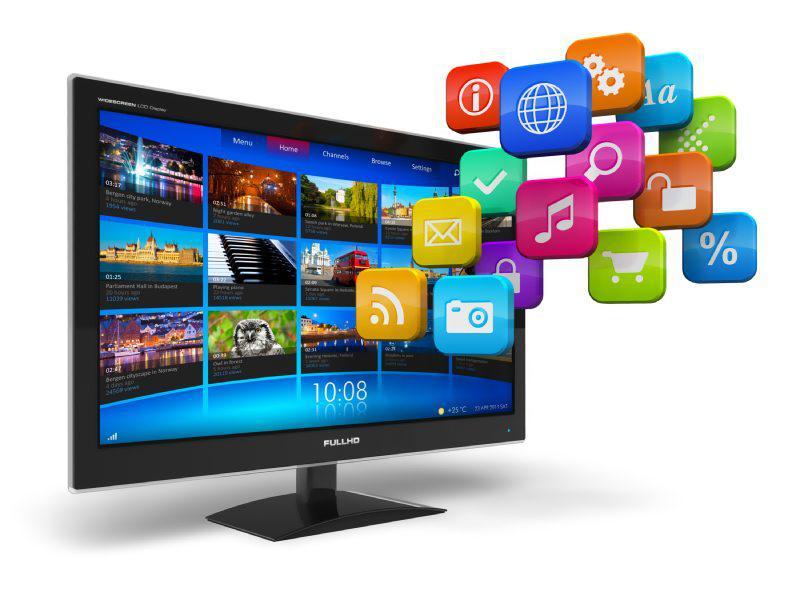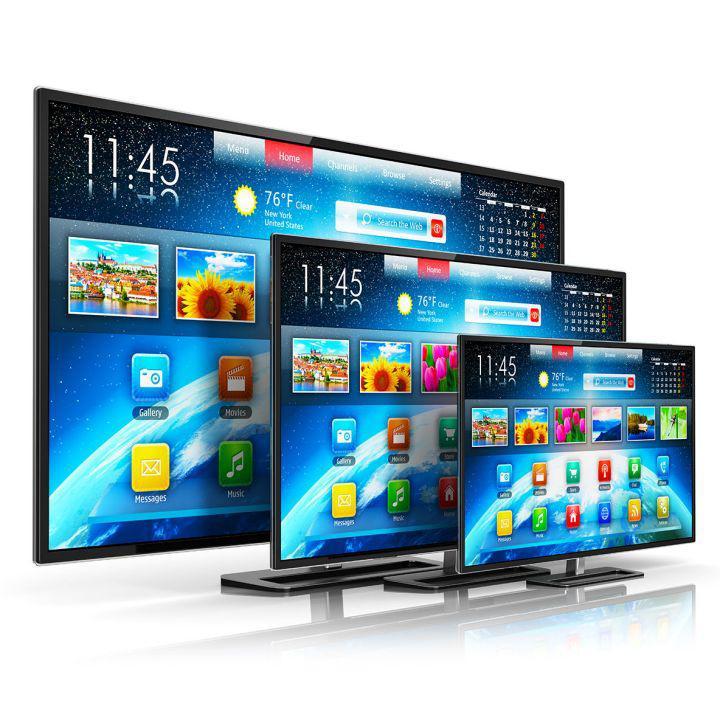The first image is the image on the left, the second image is the image on the right. Evaluate the accuracy of this statement regarding the images: "One television has a pair of end stands.". Is it true? Answer yes or no. No. The first image is the image on the left, the second image is the image on the right. Considering the images on both sides, is "Each image shows a head-on view of one flat-screen TV on a short black stand, and each TV screen displays a watery blue scene." valid? Answer yes or no. No. 